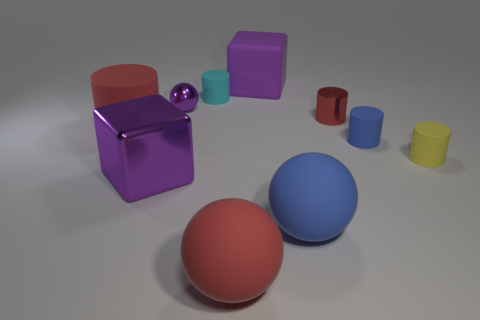Is there a cyan cylinder that has the same size as the purple sphere?
Make the answer very short. Yes. How big is the purple cube in front of the tiny blue matte object?
Provide a succinct answer. Large. What size is the cyan thing?
Offer a very short reply. Small. How many balls are either tiny objects or tiny yellow rubber things?
Keep it short and to the point. 1. What is the size of the red thing that is the same material as the big cylinder?
Offer a terse response. Large. What number of objects have the same color as the rubber block?
Offer a terse response. 2. There is a tiny yellow rubber cylinder; are there any big rubber blocks in front of it?
Your answer should be compact. No. There is a yellow object; is it the same shape as the large red thing behind the big blue matte ball?
Make the answer very short. Yes. How many objects are either tiny cylinders to the left of the large rubber block or small cyan balls?
Offer a very short reply. 1. What number of large objects are both in front of the red matte cylinder and behind the tiny cyan thing?
Ensure brevity in your answer.  0. 